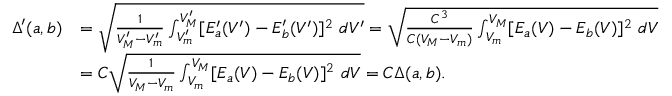Convert formula to latex. <formula><loc_0><loc_0><loc_500><loc_500>\begin{array} { r l } { \Delta ^ { \prime } ( a , b ) } & { = \sqrt { \frac { 1 } { V _ { M } ^ { \prime } - V _ { m } ^ { \prime } } \int _ { V _ { m } ^ { \prime } } ^ { V _ { M } ^ { \prime } } [ E _ { a } ^ { \prime } ( V ^ { \prime } ) - E _ { b } ^ { \prime } ( V ^ { \prime } ) ] ^ { 2 } d V ^ { \prime } } = \sqrt { \frac { C ^ { 3 } } { C ( V _ { M } - V _ { m } ) } \int _ { V _ { m } } ^ { V _ { M } } [ E _ { a } ( V ) - E _ { b } ( V ) ] ^ { 2 } d V } } \\ & { = C \sqrt { \frac { 1 } { V _ { M } - V _ { m } } \int _ { V _ { m } } ^ { V _ { M } } [ E _ { a } ( V ) - E _ { b } ( V ) ] ^ { 2 } d V } = C \Delta ( a , b ) . } \end{array}</formula> 